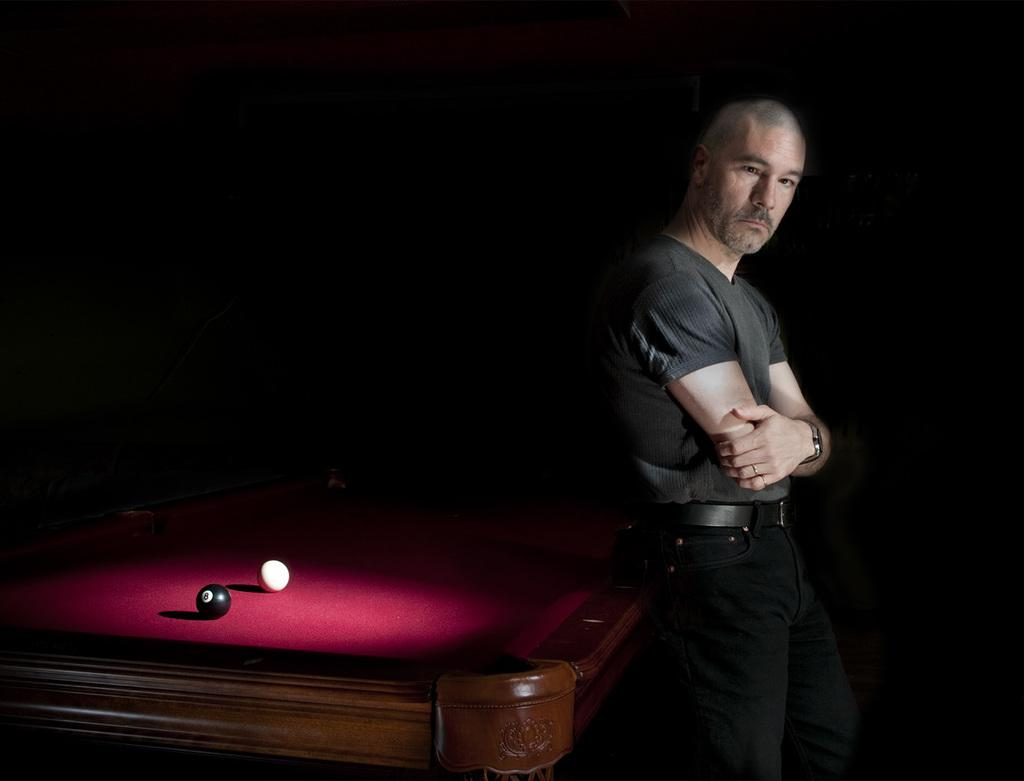What is the person in the image wearing? The person is wearing a grey shirt in the image. What is the person doing in the image? The person is leaning on a snooker table. What type of balls are on the snooker table? Black and white balls are placed on the snooker table. What color is the mat on the snooker table? The snooker table has a red mat on it. What type of produce is the person holding in the image? There is no produce present in the image; the person is leaning on a snooker table. 